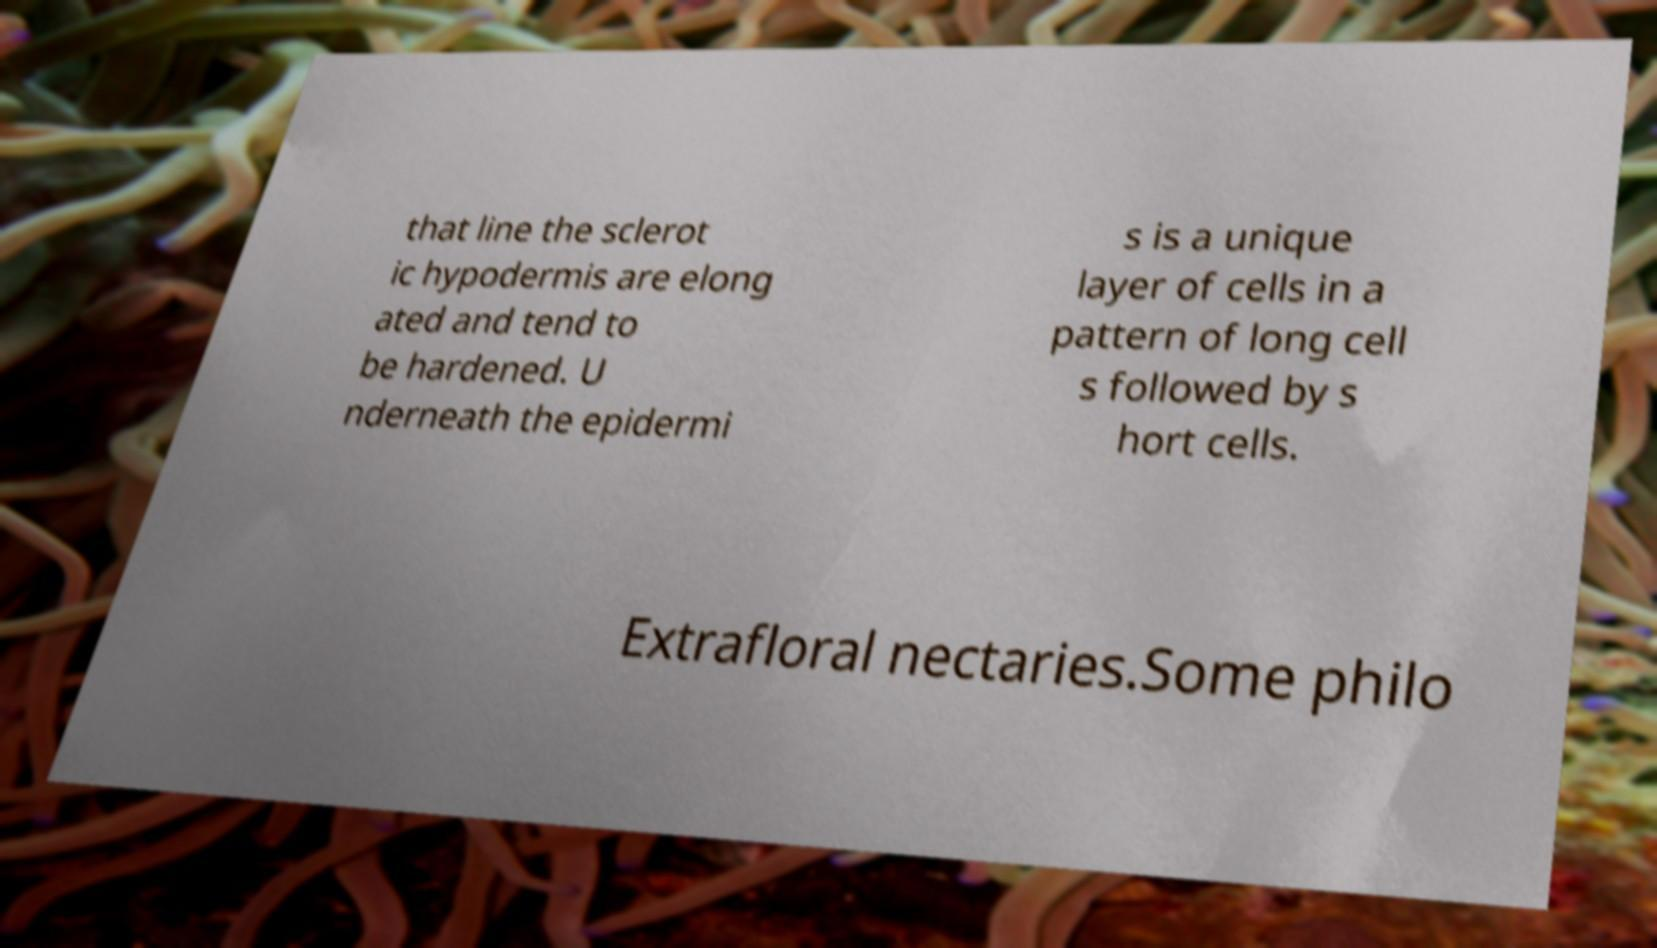Can you read and provide the text displayed in the image?This photo seems to have some interesting text. Can you extract and type it out for me? that line the sclerot ic hypodermis are elong ated and tend to be hardened. U nderneath the epidermi s is a unique layer of cells in a pattern of long cell s followed by s hort cells. Extrafloral nectaries.Some philo 